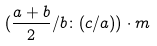Convert formula to latex. <formula><loc_0><loc_0><loc_500><loc_500>( \frac { a + b } { 2 } / b \colon ( c / a ) ) \cdot m</formula> 